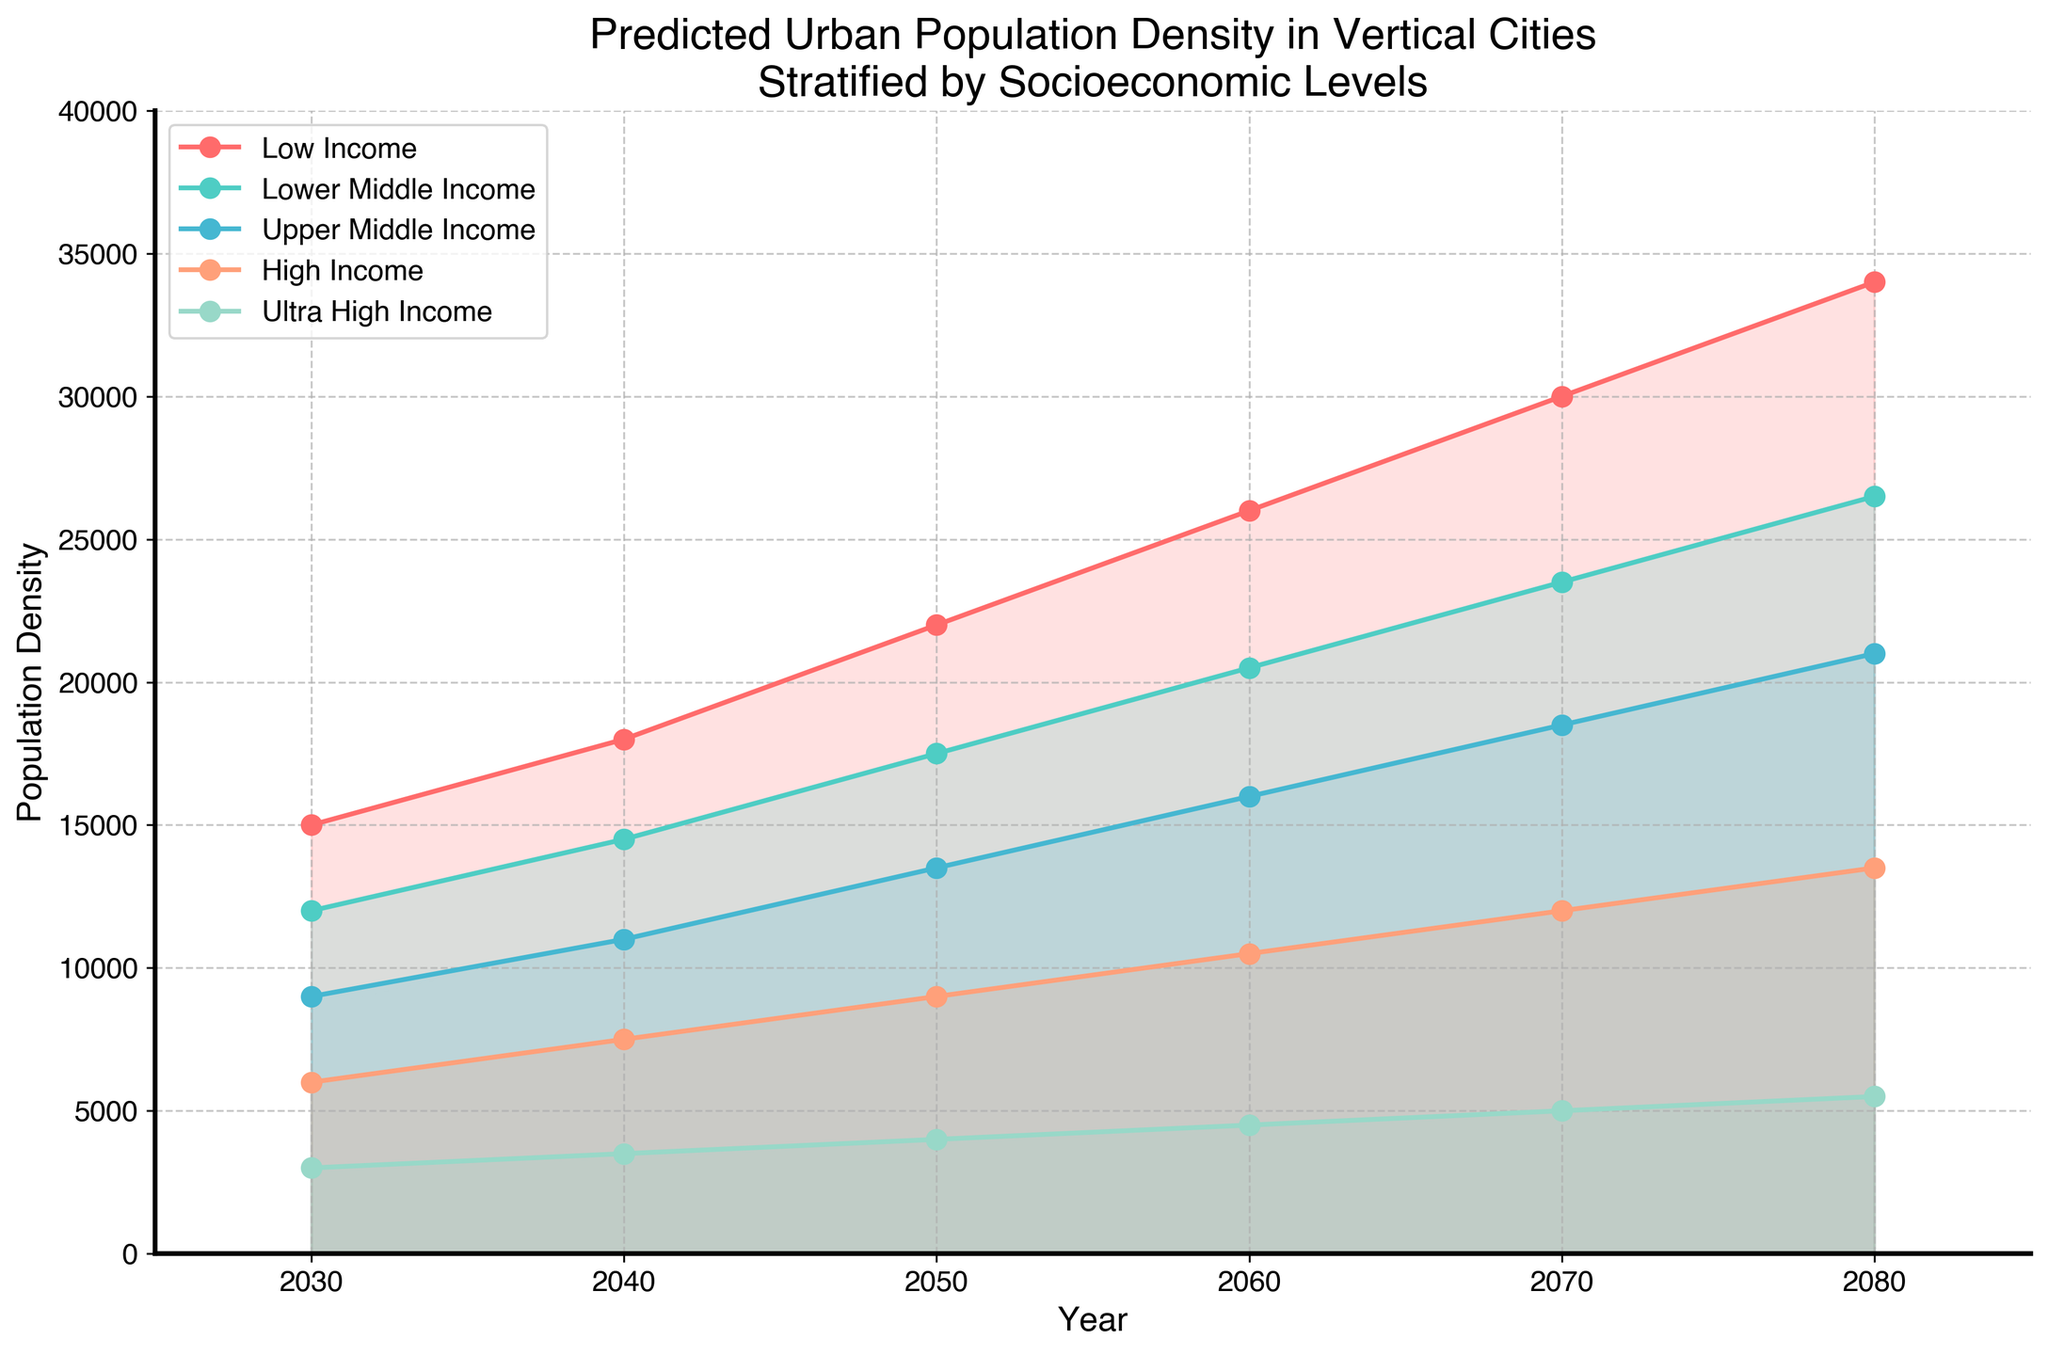What is the title of the figure? The title is located at the top of the figure and provides a concise summary of what the figure illustrates.
Answer: Predicted Urban Population Density in Vertical Cities Stratified by Socioeconomic Levels How many socioeconomic levels are shown in the figure? The legend on the right side of the figure displays the different categories. Counting them gives the total number of socioeconomic levels.
Answer: 5 Which socioeconomic level has the steepest increase in population density from 2030 to 2040? By observing the slopes of the lines for each group from 2030 to 2040, we can determine which one increases the most. The "Low Income" group shows the steepest increase in this period.
Answer: Low Income What is the population density for the High Income group in the year 2060? Locate the High Income group in the legend, then follow this group's line on the chart until the year 2060 on the x-axis. The value indicated on the y-axis is the population density.
Answer: 10,500 By how much does the population density increase for the Upper Middle Income group from 2050 to 2070? Find the population densities for the Upper Middle Income group for the years 2050 and 2070 and subtract the earlier value from the later one. The increase is 18,500 - 13,500 = 5,000.
Answer: 5,000 Which socioeconomic level is predicted to have the lowest population density in 2080? Look at the y-values for each group at the year 2080 on the x-axis and compare. The Ultra High Income group is predicted to have the lowest population density at that point.
Answer: Ultra High Income What is the approximate difference in population density between the Low Income and High Income groups in 2030? Find the population densities for both the Low Income and High Income groups in 2030 and subtract the High Income value from the Low Income value. The difference is 15,000 - 6,000 = 9,000.
Answer: 9,000 Between which years does the population density of the Lower Middle Income group surpass that of the High Income group? Track the lines for both groups and identify the interval where the Lower Middle Income line crosses above the High Income line. The Lower Middle Income group surpasses the High Income group between 2030 and 2040.
Answer: 2030 and 2040 What can be inferred about the trend in population density for vertical cities in the Ultra High Income group from 2030 to 2080? By observing the curve for the Ultra High Income group from 2030 to 2080, it is clear the population density increases steadily over this period.
Answer: Steadily increasing 